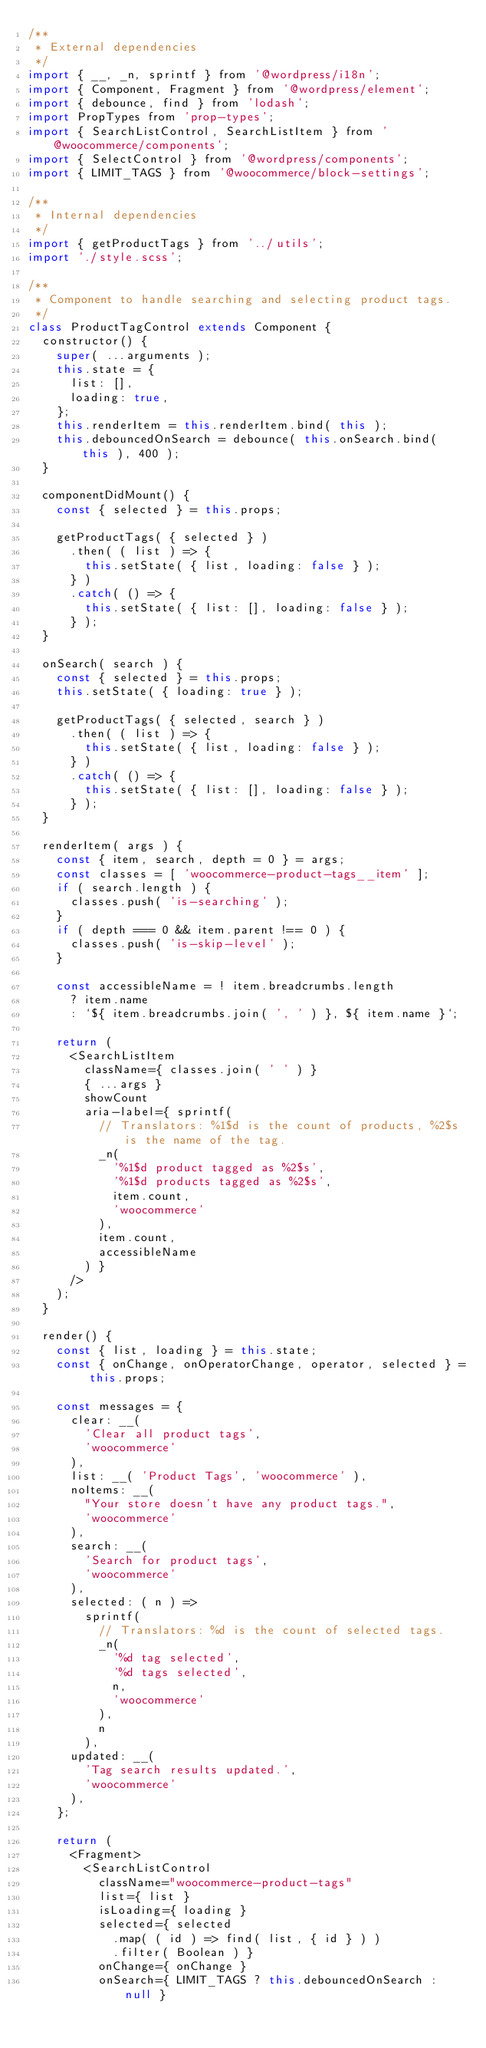Convert code to text. <code><loc_0><loc_0><loc_500><loc_500><_JavaScript_>/**
 * External dependencies
 */
import { __, _n, sprintf } from '@wordpress/i18n';
import { Component, Fragment } from '@wordpress/element';
import { debounce, find } from 'lodash';
import PropTypes from 'prop-types';
import { SearchListControl, SearchListItem } from '@woocommerce/components';
import { SelectControl } from '@wordpress/components';
import { LIMIT_TAGS } from '@woocommerce/block-settings';

/**
 * Internal dependencies
 */
import { getProductTags } from '../utils';
import './style.scss';

/**
 * Component to handle searching and selecting product tags.
 */
class ProductTagControl extends Component {
	constructor() {
		super( ...arguments );
		this.state = {
			list: [],
			loading: true,
		};
		this.renderItem = this.renderItem.bind( this );
		this.debouncedOnSearch = debounce( this.onSearch.bind( this ), 400 );
	}

	componentDidMount() {
		const { selected } = this.props;

		getProductTags( { selected } )
			.then( ( list ) => {
				this.setState( { list, loading: false } );
			} )
			.catch( () => {
				this.setState( { list: [], loading: false } );
			} );
	}

	onSearch( search ) {
		const { selected } = this.props;
		this.setState( { loading: true } );

		getProductTags( { selected, search } )
			.then( ( list ) => {
				this.setState( { list, loading: false } );
			} )
			.catch( () => {
				this.setState( { list: [], loading: false } );
			} );
	}

	renderItem( args ) {
		const { item, search, depth = 0 } = args;
		const classes = [ 'woocommerce-product-tags__item' ];
		if ( search.length ) {
			classes.push( 'is-searching' );
		}
		if ( depth === 0 && item.parent !== 0 ) {
			classes.push( 'is-skip-level' );
		}

		const accessibleName = ! item.breadcrumbs.length
			? item.name
			: `${ item.breadcrumbs.join( ', ' ) }, ${ item.name }`;

		return (
			<SearchListItem
				className={ classes.join( ' ' ) }
				{ ...args }
				showCount
				aria-label={ sprintf(
					// Translators: %1$d is the count of products, %2$s is the name of the tag.
					_n(
						'%1$d product tagged as %2$s',
						'%1$d products tagged as %2$s',
						item.count,
						'woocommerce'
					),
					item.count,
					accessibleName
				) }
			/>
		);
	}

	render() {
		const { list, loading } = this.state;
		const { onChange, onOperatorChange, operator, selected } = this.props;

		const messages = {
			clear: __(
				'Clear all product tags',
				'woocommerce'
			),
			list: __( 'Product Tags', 'woocommerce' ),
			noItems: __(
				"Your store doesn't have any product tags.",
				'woocommerce'
			),
			search: __(
				'Search for product tags',
				'woocommerce'
			),
			selected: ( n ) =>
				sprintf(
					// Translators: %d is the count of selected tags.
					_n(
						'%d tag selected',
						'%d tags selected',
						n,
						'woocommerce'
					),
					n
				),
			updated: __(
				'Tag search results updated.',
				'woocommerce'
			),
		};

		return (
			<Fragment>
				<SearchListControl
					className="woocommerce-product-tags"
					list={ list }
					isLoading={ loading }
					selected={ selected
						.map( ( id ) => find( list, { id } ) )
						.filter( Boolean ) }
					onChange={ onChange }
					onSearch={ LIMIT_TAGS ? this.debouncedOnSearch : null }</code> 